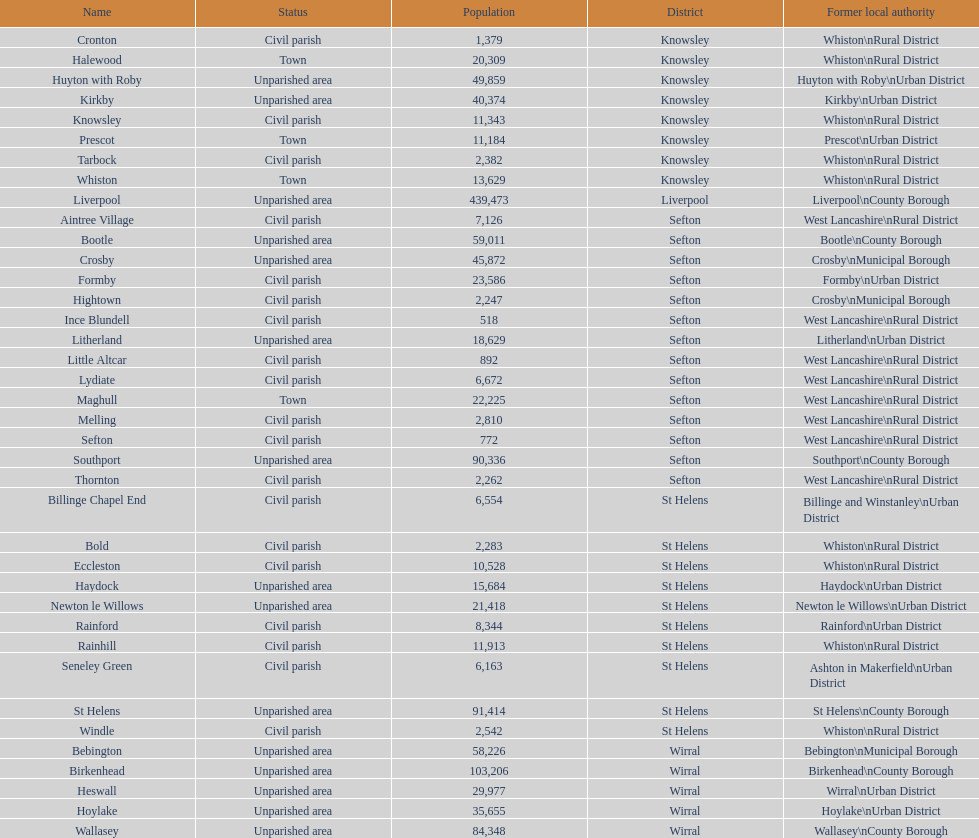How many civil parishes have population counts of at least 10,000? 4. 